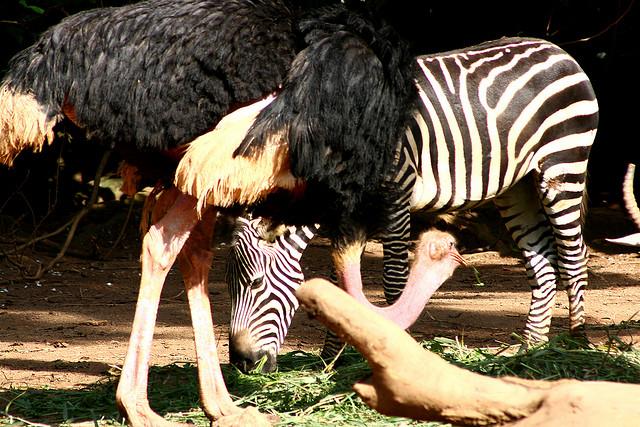What does the ostrich and zebra have in common?
Quick response, please. Black. What color are the zebras stripes?
Answer briefly. Black and white. Are these two types of animals?
Short answer required. Yes. Which animals are these?
Write a very short answer. Zebra and ostrich. 